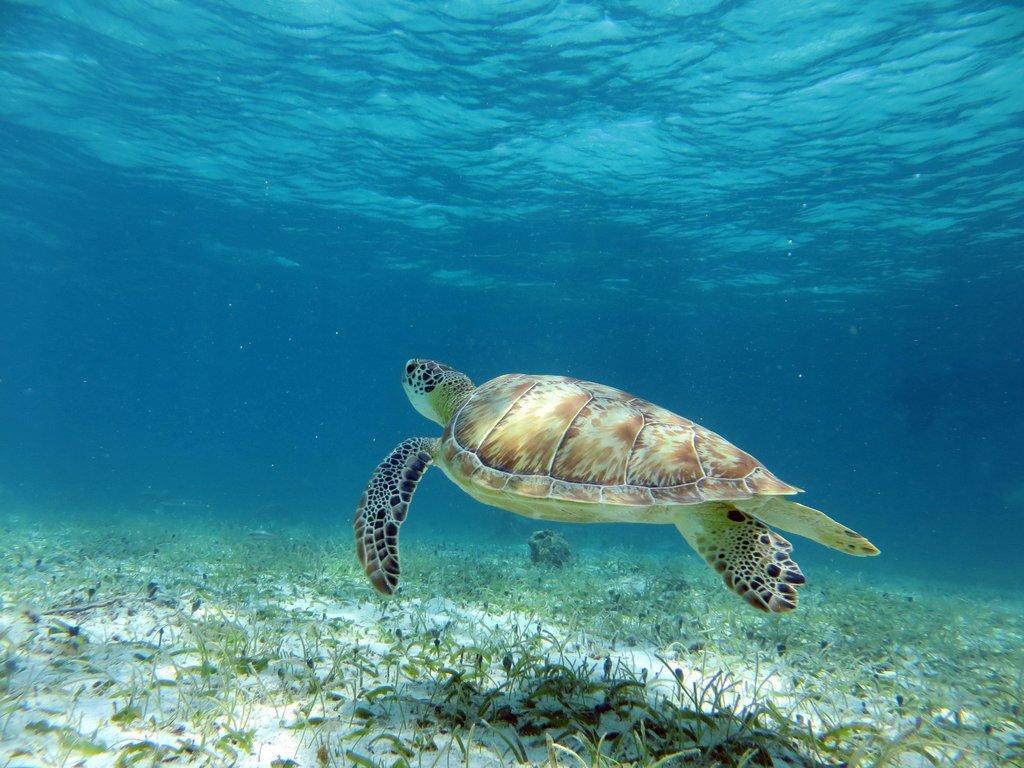Describe this image in one or two sentences. In this image I can see tortoise which is in brown,white and black color. It is inside the water. I can see green grass. Background is in blue color. 